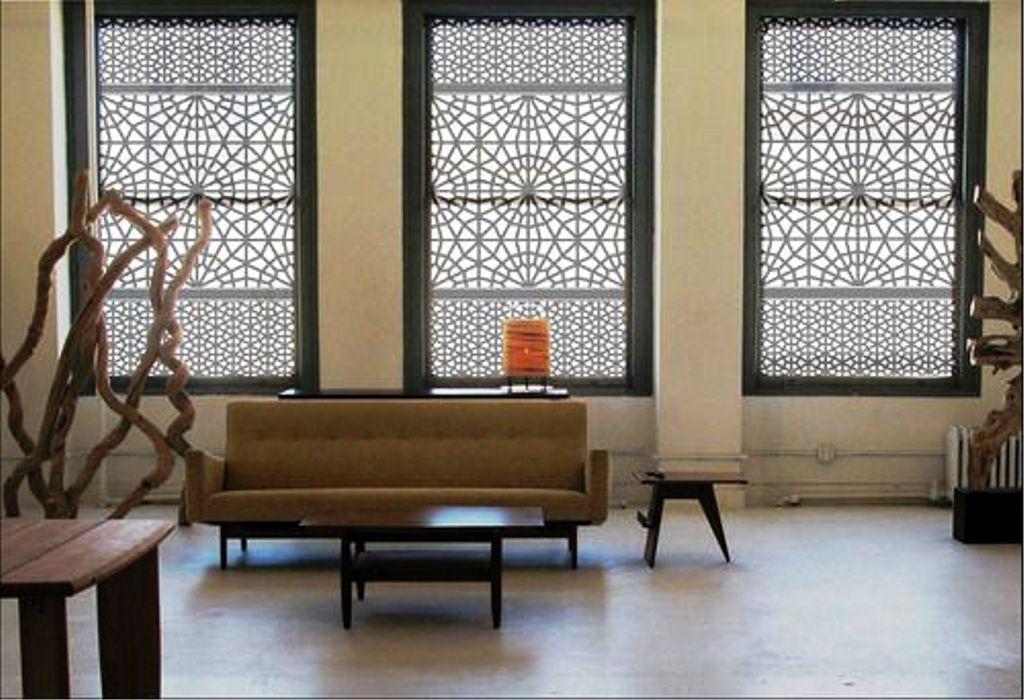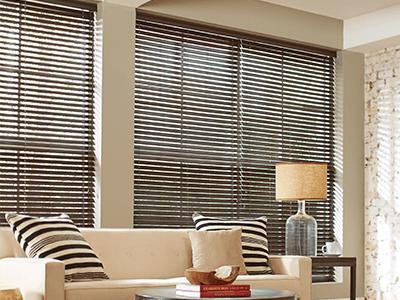The first image is the image on the left, the second image is the image on the right. Given the left and right images, does the statement "An image shows a motel-type room with beige drapes on a big window, and a TV on a wooden stand." hold true? Answer yes or no. No. The first image is the image on the left, the second image is the image on the right. For the images displayed, is the sentence "There are open vertical blinds in the left image." factually correct? Answer yes or no. No. 